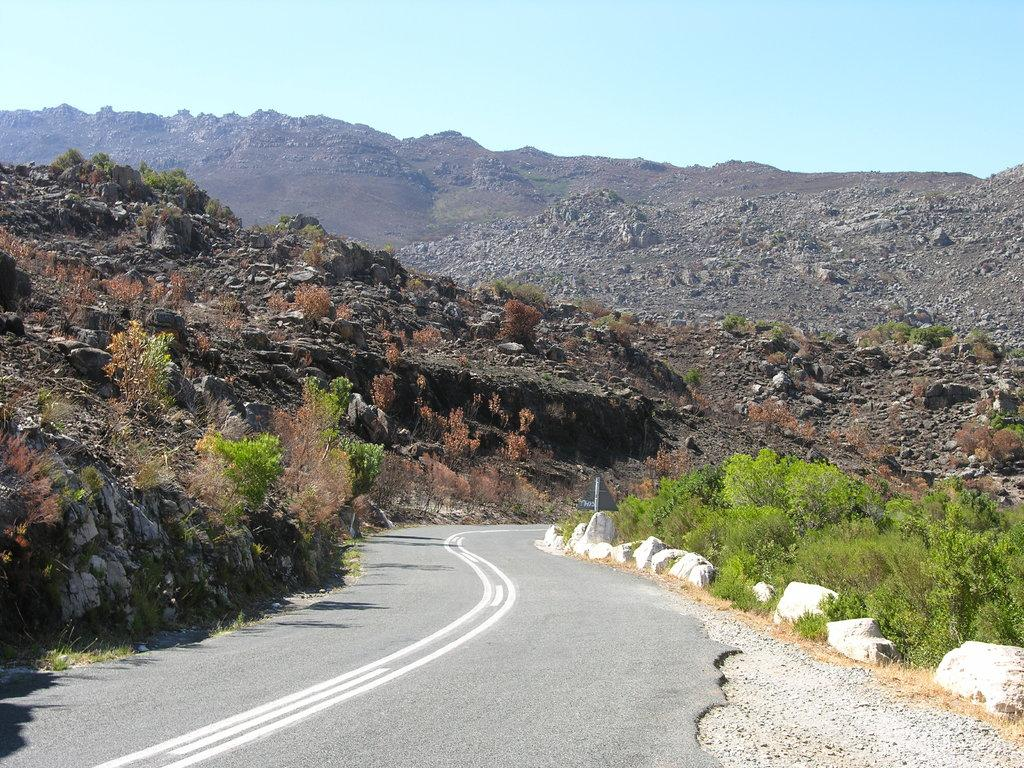What is the main feature of the image? There is a road in the image. What can be observed about the road? The road has white lines. What other elements are present in the image? There are rocks, plants, and mountains in the image. What is visible in the background of the image? The sky is blue in the background of the image. What type of reaction does the jewel have when exposed to sunlight in the image? There is no jewel present in the image, so it is not possible to determine any reaction to sunlight. What color are the eyes of the person in the image? There is no person present in the image, so it is not possible to determine the color of their eyes. 